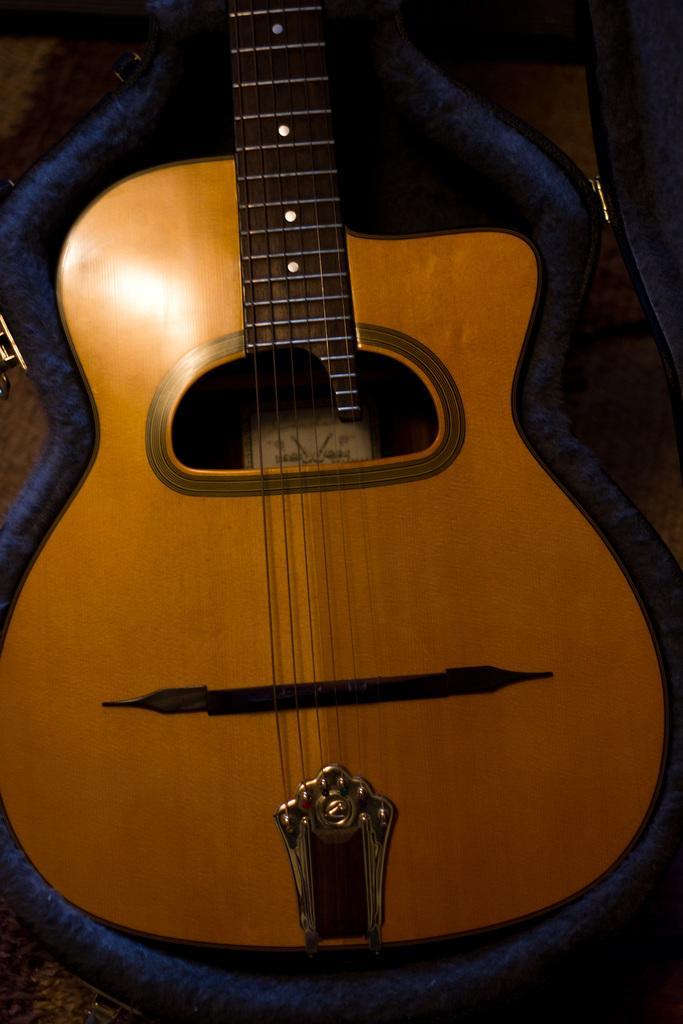In one or two sentences, can you explain what this image depicts? In this image there is one guitar and one guitar cover is there. 